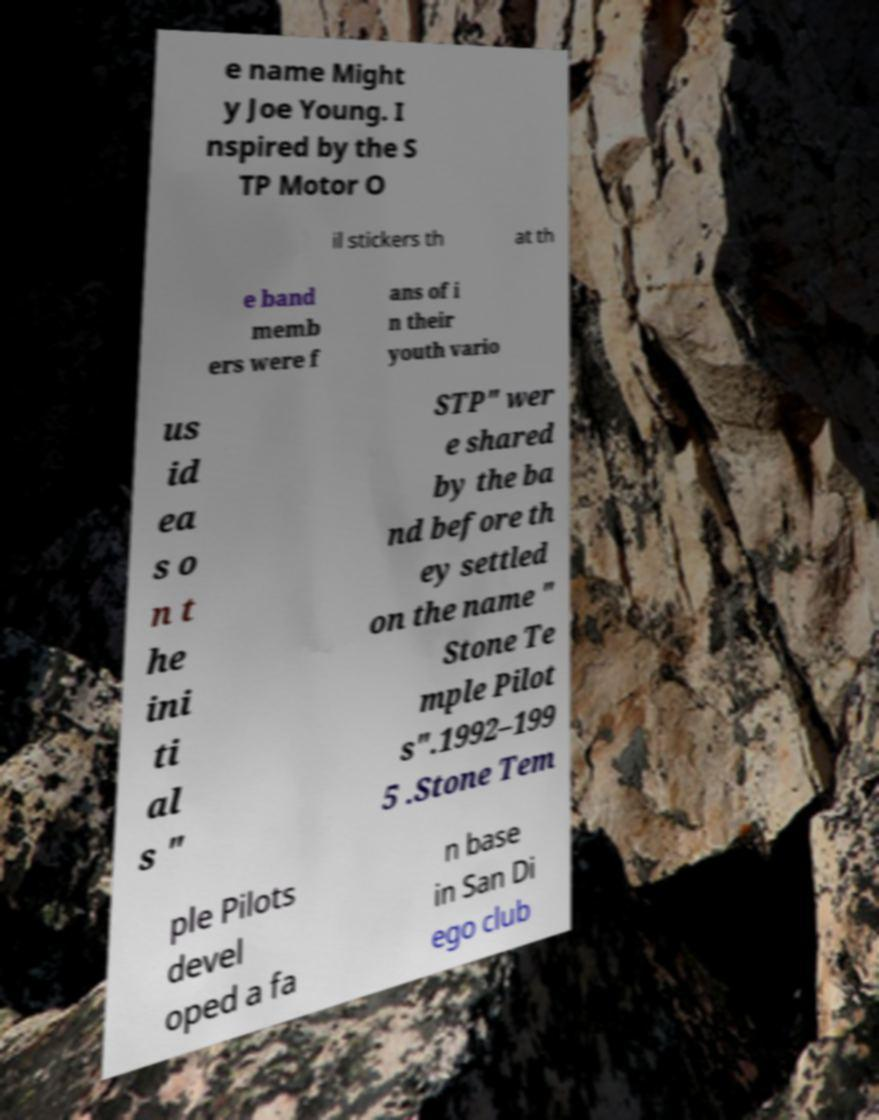Could you extract and type out the text from this image? e name Might y Joe Young. I nspired by the S TP Motor O il stickers th at th e band memb ers were f ans of i n their youth vario us id ea s o n t he ini ti al s " STP" wer e shared by the ba nd before th ey settled on the name " Stone Te mple Pilot s".1992–199 5 .Stone Tem ple Pilots devel oped a fa n base in San Di ego club 